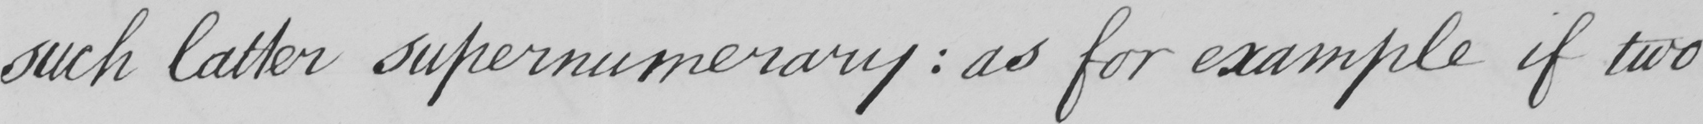Please transcribe the handwritten text in this image. such latter supernumerary  :  as for example if two 